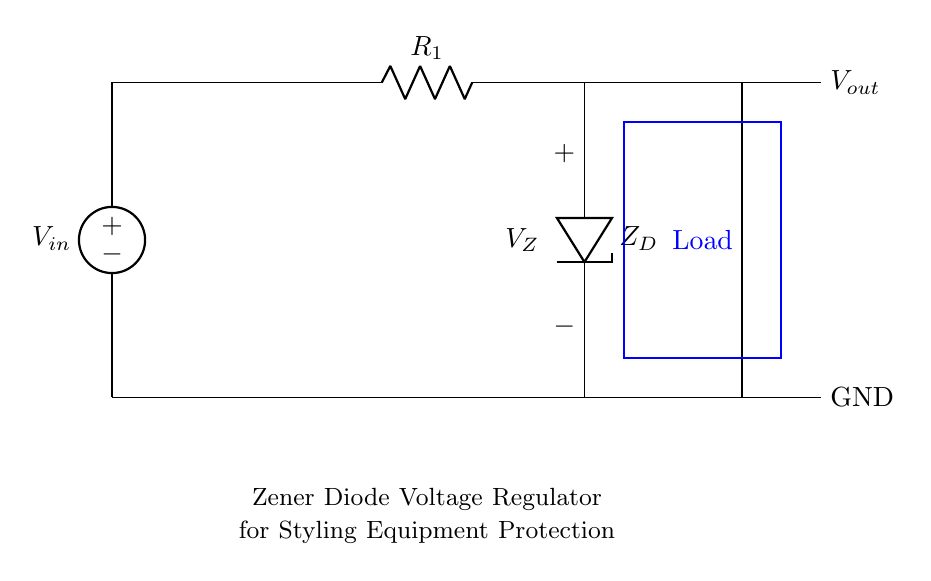What is the input voltage of the circuit? The input voltage, noted as V_in in the diagram, is the voltage supplied to the circuit, which can vary based on the power source. Since it is not specified in the drawing, we understand that it connects to a voltage source that must be higher than the zener breakdown voltage.
Answer: V_in What is the component labeled as Z_D? The component labeled Z_D represents the zener diode in the circuit, which is used for voltage regulation. It allows current to flow in the reverse direction when the voltage exceeds a certain level, maintaining a constant output voltage.
Answer: Zener diode What does the load in this circuit represent? The load, indicated by a rectangle in the circuit diagram, represents the sensitive styling equipment that requires regulated voltage to operate safely. This signifies the part of the circuit where the output voltage is applied.
Answer: Sensitive equipment What is the purpose of the resistor R_1 in the circuit? The resistor R_1 serves to limit the current flowing through the zener diode, preventing it from overheating and ensuring that the diode operates within its safe limits. This helps in stabilizing the output voltage across the load.
Answer: Current limiter What will happen when the input voltage exceeds the zener voltage V_Z? When the input voltage surpasses the zener voltage, the zener diode will enter breakdown mode, allowing excess voltage to be shunted to ground while maintaining the output voltage at V_Z, thus protecting the load from surges.
Answer: Output remains V_Z What is the output voltage V_out in relation to the zener diode? The output voltage V_out is maintained at the zener voltage V_Z, regardless of variations in the input voltage, as long as the input voltage exceeds V_Z. This stable output ensures that connected equipment operates safely during load shedding recovery.
Answer: V_Z 